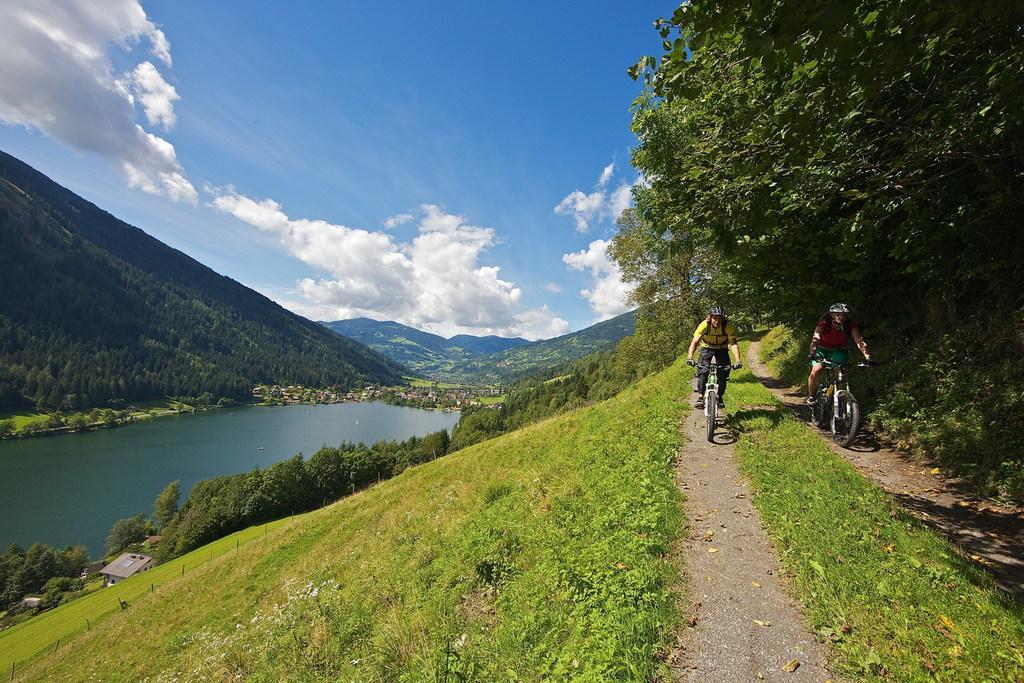In one or two sentences, can you explain what this image depicts? In the image in the center we can see two persons were riding the cycle and they were wearing helmet. In the background we can see the sky,clouds,water,hills,trees,plants and grass. 